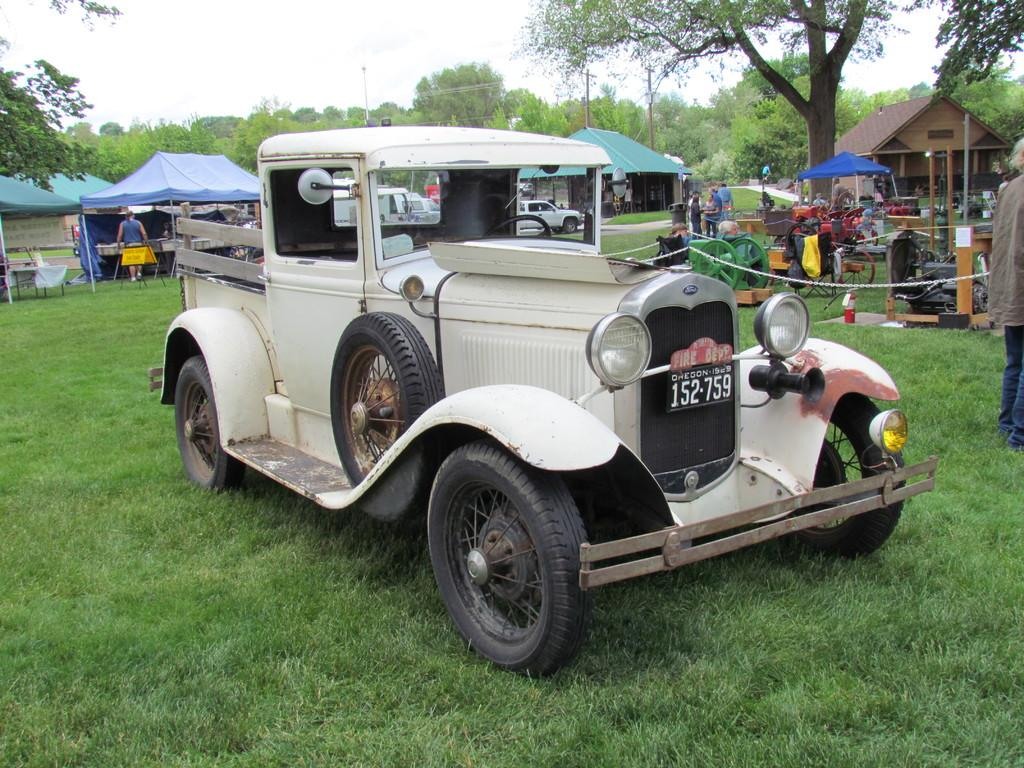What is the main subject of the image? There is a car in the image. What can be seen in the background of the image? In the background of the image, there are stalls, tents with poles, a group of people, trees, grass, a house, and the sky. Can you describe the setting of the image? The image appears to be set in an outdoor area with a mix of natural and man-made elements, such as trees, grass, tents, stalls, and a house. How many kittens are playing with the apparatus in the image? There are no kittens or apparatus present in the image. What color are the eyes of the person standing in the background of the image? The image does not provide enough detail to determine the color of anyone's eyes. 